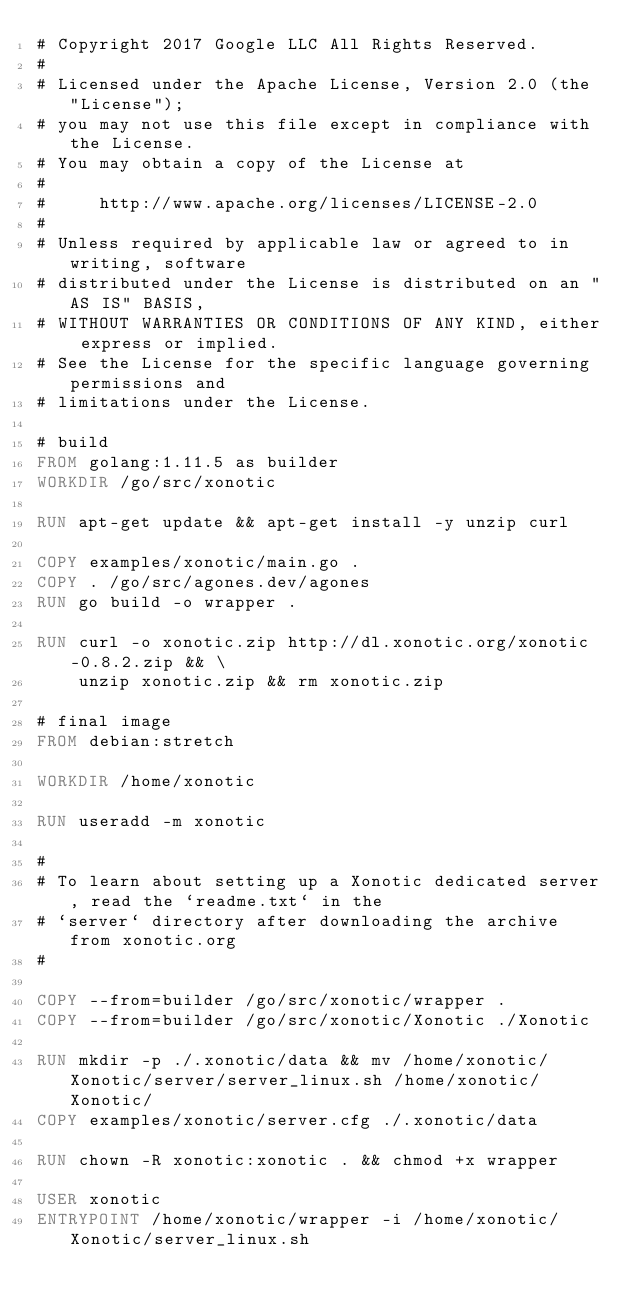<code> <loc_0><loc_0><loc_500><loc_500><_Dockerfile_># Copyright 2017 Google LLC All Rights Reserved.
#
# Licensed under the Apache License, Version 2.0 (the "License");
# you may not use this file except in compliance with the License.
# You may obtain a copy of the License at
#
#     http://www.apache.org/licenses/LICENSE-2.0
#
# Unless required by applicable law or agreed to in writing, software
# distributed under the License is distributed on an "AS IS" BASIS,
# WITHOUT WARRANTIES OR CONDITIONS OF ANY KIND, either express or implied.
# See the License for the specific language governing permissions and
# limitations under the License.

# build
FROM golang:1.11.5 as builder
WORKDIR /go/src/xonotic

RUN apt-get update && apt-get install -y unzip curl

COPY examples/xonotic/main.go .
COPY . /go/src/agones.dev/agones
RUN go build -o wrapper .

RUN curl -o xonotic.zip http://dl.xonotic.org/xonotic-0.8.2.zip && \
    unzip xonotic.zip && rm xonotic.zip

# final image
FROM debian:stretch

WORKDIR /home/xonotic

RUN useradd -m xonotic

#
# To learn about setting up a Xonotic dedicated server, read the `readme.txt` in the
# `server` directory after downloading the archive from xonotic.org
#

COPY --from=builder /go/src/xonotic/wrapper .
COPY --from=builder /go/src/xonotic/Xonotic ./Xonotic

RUN mkdir -p ./.xonotic/data && mv /home/xonotic/Xonotic/server/server_linux.sh /home/xonotic/Xonotic/
COPY examples/xonotic/server.cfg ./.xonotic/data

RUN chown -R xonotic:xonotic . && chmod +x wrapper

USER xonotic
ENTRYPOINT /home/xonotic/wrapper -i /home/xonotic/Xonotic/server_linux.sh
</code> 